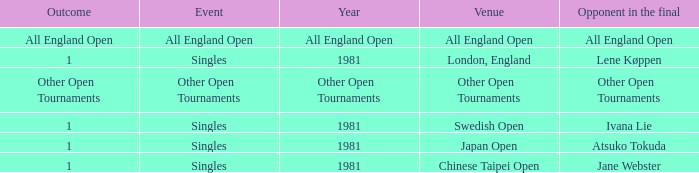In which event can the outcome be the initiation of other open tournaments? Other Open Tournaments. 